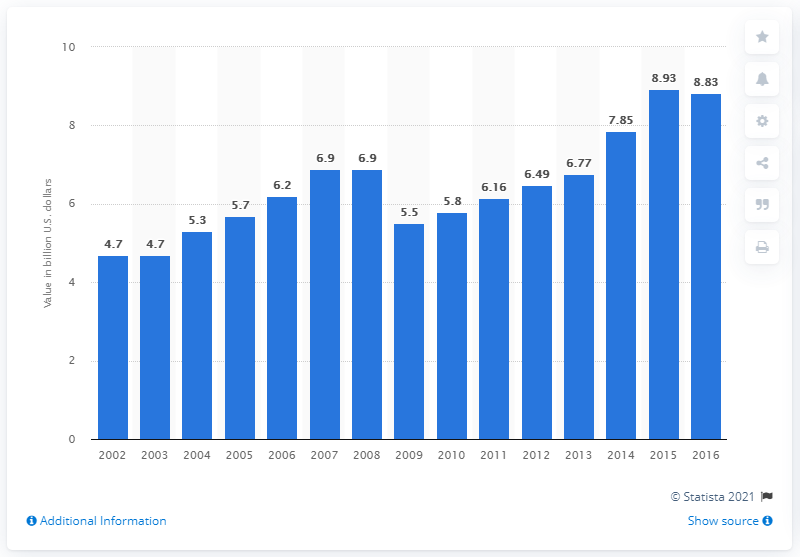Give some essential details in this illustration. In 2009, the value of U.S. product shipments of wood containers and pallets was $5.5 billion. 